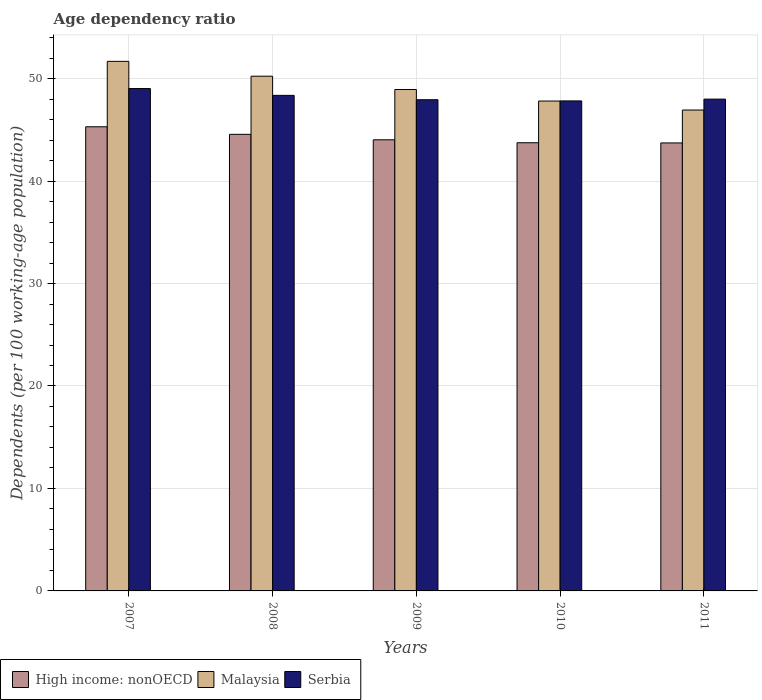How many bars are there on the 4th tick from the right?
Your response must be concise. 3. What is the age dependency ratio in in Serbia in 2008?
Your answer should be compact. 48.36. Across all years, what is the maximum age dependency ratio in in High income: nonOECD?
Make the answer very short. 45.3. Across all years, what is the minimum age dependency ratio in in Malaysia?
Keep it short and to the point. 46.93. What is the total age dependency ratio in in High income: nonOECD in the graph?
Your response must be concise. 221.35. What is the difference between the age dependency ratio in in High income: nonOECD in 2007 and that in 2011?
Offer a very short reply. 1.58. What is the difference between the age dependency ratio in in Serbia in 2011 and the age dependency ratio in in High income: nonOECD in 2009?
Ensure brevity in your answer.  3.97. What is the average age dependency ratio in in Malaysia per year?
Make the answer very short. 49.12. In the year 2008, what is the difference between the age dependency ratio in in Malaysia and age dependency ratio in in High income: nonOECD?
Your answer should be compact. 5.67. In how many years, is the age dependency ratio in in High income: nonOECD greater than 14 %?
Your answer should be compact. 5. What is the ratio of the age dependency ratio in in High income: nonOECD in 2007 to that in 2011?
Your response must be concise. 1.04. Is the age dependency ratio in in Serbia in 2008 less than that in 2009?
Your answer should be very brief. No. Is the difference between the age dependency ratio in in Malaysia in 2007 and 2010 greater than the difference between the age dependency ratio in in High income: nonOECD in 2007 and 2010?
Provide a succinct answer. Yes. What is the difference between the highest and the second highest age dependency ratio in in Serbia?
Offer a terse response. 0.66. What is the difference between the highest and the lowest age dependency ratio in in Serbia?
Your response must be concise. 1.21. What does the 3rd bar from the left in 2011 represents?
Give a very brief answer. Serbia. What does the 1st bar from the right in 2010 represents?
Ensure brevity in your answer.  Serbia. Is it the case that in every year, the sum of the age dependency ratio in in Serbia and age dependency ratio in in Malaysia is greater than the age dependency ratio in in High income: nonOECD?
Your answer should be very brief. Yes. How many bars are there?
Your answer should be very brief. 15. What is the difference between two consecutive major ticks on the Y-axis?
Make the answer very short. 10. Are the values on the major ticks of Y-axis written in scientific E-notation?
Ensure brevity in your answer.  No. Does the graph contain grids?
Your response must be concise. Yes. How are the legend labels stacked?
Make the answer very short. Horizontal. What is the title of the graph?
Your response must be concise. Age dependency ratio. What is the label or title of the X-axis?
Provide a succinct answer. Years. What is the label or title of the Y-axis?
Keep it short and to the point. Dependents (per 100 working-age population). What is the Dependents (per 100 working-age population) of High income: nonOECD in 2007?
Your answer should be very brief. 45.3. What is the Dependents (per 100 working-age population) of Malaysia in 2007?
Your response must be concise. 51.68. What is the Dependents (per 100 working-age population) in Serbia in 2007?
Make the answer very short. 49.03. What is the Dependents (per 100 working-age population) in High income: nonOECD in 2008?
Make the answer very short. 44.56. What is the Dependents (per 100 working-age population) of Malaysia in 2008?
Offer a terse response. 50.23. What is the Dependents (per 100 working-age population) in Serbia in 2008?
Your answer should be very brief. 48.36. What is the Dependents (per 100 working-age population) in High income: nonOECD in 2009?
Your response must be concise. 44.03. What is the Dependents (per 100 working-age population) in Malaysia in 2009?
Keep it short and to the point. 48.94. What is the Dependents (per 100 working-age population) of Serbia in 2009?
Your answer should be compact. 47.94. What is the Dependents (per 100 working-age population) of High income: nonOECD in 2010?
Offer a terse response. 43.74. What is the Dependents (per 100 working-age population) of Malaysia in 2010?
Your answer should be compact. 47.81. What is the Dependents (per 100 working-age population) in Serbia in 2010?
Your answer should be very brief. 47.82. What is the Dependents (per 100 working-age population) in High income: nonOECD in 2011?
Give a very brief answer. 43.72. What is the Dependents (per 100 working-age population) in Malaysia in 2011?
Your answer should be compact. 46.93. What is the Dependents (per 100 working-age population) of Serbia in 2011?
Make the answer very short. 48. Across all years, what is the maximum Dependents (per 100 working-age population) of High income: nonOECD?
Your answer should be compact. 45.3. Across all years, what is the maximum Dependents (per 100 working-age population) of Malaysia?
Your answer should be very brief. 51.68. Across all years, what is the maximum Dependents (per 100 working-age population) in Serbia?
Your answer should be very brief. 49.03. Across all years, what is the minimum Dependents (per 100 working-age population) in High income: nonOECD?
Keep it short and to the point. 43.72. Across all years, what is the minimum Dependents (per 100 working-age population) of Malaysia?
Your answer should be very brief. 46.93. Across all years, what is the minimum Dependents (per 100 working-age population) of Serbia?
Give a very brief answer. 47.82. What is the total Dependents (per 100 working-age population) in High income: nonOECD in the graph?
Provide a short and direct response. 221.35. What is the total Dependents (per 100 working-age population) of Malaysia in the graph?
Give a very brief answer. 245.6. What is the total Dependents (per 100 working-age population) in Serbia in the graph?
Your response must be concise. 241.15. What is the difference between the Dependents (per 100 working-age population) in High income: nonOECD in 2007 and that in 2008?
Offer a very short reply. 0.74. What is the difference between the Dependents (per 100 working-age population) in Malaysia in 2007 and that in 2008?
Offer a terse response. 1.45. What is the difference between the Dependents (per 100 working-age population) of Serbia in 2007 and that in 2008?
Offer a terse response. 0.66. What is the difference between the Dependents (per 100 working-age population) of High income: nonOECD in 2007 and that in 2009?
Provide a succinct answer. 1.27. What is the difference between the Dependents (per 100 working-age population) in Malaysia in 2007 and that in 2009?
Your response must be concise. 2.75. What is the difference between the Dependents (per 100 working-age population) in Serbia in 2007 and that in 2009?
Your answer should be very brief. 1.09. What is the difference between the Dependents (per 100 working-age population) in High income: nonOECD in 2007 and that in 2010?
Your response must be concise. 1.56. What is the difference between the Dependents (per 100 working-age population) in Malaysia in 2007 and that in 2010?
Provide a short and direct response. 3.87. What is the difference between the Dependents (per 100 working-age population) in Serbia in 2007 and that in 2010?
Offer a terse response. 1.21. What is the difference between the Dependents (per 100 working-age population) of High income: nonOECD in 2007 and that in 2011?
Your answer should be compact. 1.58. What is the difference between the Dependents (per 100 working-age population) of Malaysia in 2007 and that in 2011?
Your response must be concise. 4.75. What is the difference between the Dependents (per 100 working-age population) in Serbia in 2007 and that in 2011?
Keep it short and to the point. 1.03. What is the difference between the Dependents (per 100 working-age population) in High income: nonOECD in 2008 and that in 2009?
Offer a terse response. 0.53. What is the difference between the Dependents (per 100 working-age population) of Malaysia in 2008 and that in 2009?
Provide a short and direct response. 1.3. What is the difference between the Dependents (per 100 working-age population) of Serbia in 2008 and that in 2009?
Your response must be concise. 0.43. What is the difference between the Dependents (per 100 working-age population) in High income: nonOECD in 2008 and that in 2010?
Offer a terse response. 0.82. What is the difference between the Dependents (per 100 working-age population) in Malaysia in 2008 and that in 2010?
Your answer should be very brief. 2.42. What is the difference between the Dependents (per 100 working-age population) of Serbia in 2008 and that in 2010?
Offer a terse response. 0.54. What is the difference between the Dependents (per 100 working-age population) in High income: nonOECD in 2008 and that in 2011?
Give a very brief answer. 0.84. What is the difference between the Dependents (per 100 working-age population) in Malaysia in 2008 and that in 2011?
Offer a very short reply. 3.3. What is the difference between the Dependents (per 100 working-age population) of Serbia in 2008 and that in 2011?
Provide a short and direct response. 0.37. What is the difference between the Dependents (per 100 working-age population) in High income: nonOECD in 2009 and that in 2010?
Offer a very short reply. 0.29. What is the difference between the Dependents (per 100 working-age population) of Malaysia in 2009 and that in 2010?
Provide a short and direct response. 1.13. What is the difference between the Dependents (per 100 working-age population) of Serbia in 2009 and that in 2010?
Give a very brief answer. 0.12. What is the difference between the Dependents (per 100 working-age population) of High income: nonOECD in 2009 and that in 2011?
Offer a very short reply. 0.31. What is the difference between the Dependents (per 100 working-age population) of Malaysia in 2009 and that in 2011?
Make the answer very short. 2. What is the difference between the Dependents (per 100 working-age population) of Serbia in 2009 and that in 2011?
Ensure brevity in your answer.  -0.06. What is the difference between the Dependents (per 100 working-age population) of High income: nonOECD in 2010 and that in 2011?
Provide a succinct answer. 0.02. What is the difference between the Dependents (per 100 working-age population) of Malaysia in 2010 and that in 2011?
Your response must be concise. 0.88. What is the difference between the Dependents (per 100 working-age population) in Serbia in 2010 and that in 2011?
Make the answer very short. -0.17. What is the difference between the Dependents (per 100 working-age population) of High income: nonOECD in 2007 and the Dependents (per 100 working-age population) of Malaysia in 2008?
Provide a short and direct response. -4.94. What is the difference between the Dependents (per 100 working-age population) in High income: nonOECD in 2007 and the Dependents (per 100 working-age population) in Serbia in 2008?
Keep it short and to the point. -3.07. What is the difference between the Dependents (per 100 working-age population) in Malaysia in 2007 and the Dependents (per 100 working-age population) in Serbia in 2008?
Offer a very short reply. 3.32. What is the difference between the Dependents (per 100 working-age population) of High income: nonOECD in 2007 and the Dependents (per 100 working-age population) of Malaysia in 2009?
Make the answer very short. -3.64. What is the difference between the Dependents (per 100 working-age population) in High income: nonOECD in 2007 and the Dependents (per 100 working-age population) in Serbia in 2009?
Your answer should be compact. -2.64. What is the difference between the Dependents (per 100 working-age population) of Malaysia in 2007 and the Dependents (per 100 working-age population) of Serbia in 2009?
Your answer should be very brief. 3.75. What is the difference between the Dependents (per 100 working-age population) in High income: nonOECD in 2007 and the Dependents (per 100 working-age population) in Malaysia in 2010?
Provide a succinct answer. -2.51. What is the difference between the Dependents (per 100 working-age population) in High income: nonOECD in 2007 and the Dependents (per 100 working-age population) in Serbia in 2010?
Provide a succinct answer. -2.52. What is the difference between the Dependents (per 100 working-age population) in Malaysia in 2007 and the Dependents (per 100 working-age population) in Serbia in 2010?
Offer a very short reply. 3.86. What is the difference between the Dependents (per 100 working-age population) of High income: nonOECD in 2007 and the Dependents (per 100 working-age population) of Malaysia in 2011?
Your answer should be very brief. -1.63. What is the difference between the Dependents (per 100 working-age population) of High income: nonOECD in 2007 and the Dependents (per 100 working-age population) of Serbia in 2011?
Provide a succinct answer. -2.7. What is the difference between the Dependents (per 100 working-age population) in Malaysia in 2007 and the Dependents (per 100 working-age population) in Serbia in 2011?
Give a very brief answer. 3.69. What is the difference between the Dependents (per 100 working-age population) in High income: nonOECD in 2008 and the Dependents (per 100 working-age population) in Malaysia in 2009?
Your answer should be very brief. -4.38. What is the difference between the Dependents (per 100 working-age population) of High income: nonOECD in 2008 and the Dependents (per 100 working-age population) of Serbia in 2009?
Offer a very short reply. -3.38. What is the difference between the Dependents (per 100 working-age population) in Malaysia in 2008 and the Dependents (per 100 working-age population) in Serbia in 2009?
Keep it short and to the point. 2.3. What is the difference between the Dependents (per 100 working-age population) in High income: nonOECD in 2008 and the Dependents (per 100 working-age population) in Malaysia in 2010?
Offer a terse response. -3.25. What is the difference between the Dependents (per 100 working-age population) of High income: nonOECD in 2008 and the Dependents (per 100 working-age population) of Serbia in 2010?
Provide a succinct answer. -3.26. What is the difference between the Dependents (per 100 working-age population) of Malaysia in 2008 and the Dependents (per 100 working-age population) of Serbia in 2010?
Your answer should be compact. 2.41. What is the difference between the Dependents (per 100 working-age population) of High income: nonOECD in 2008 and the Dependents (per 100 working-age population) of Malaysia in 2011?
Your answer should be very brief. -2.37. What is the difference between the Dependents (per 100 working-age population) in High income: nonOECD in 2008 and the Dependents (per 100 working-age population) in Serbia in 2011?
Provide a short and direct response. -3.44. What is the difference between the Dependents (per 100 working-age population) of Malaysia in 2008 and the Dependents (per 100 working-age population) of Serbia in 2011?
Ensure brevity in your answer.  2.24. What is the difference between the Dependents (per 100 working-age population) in High income: nonOECD in 2009 and the Dependents (per 100 working-age population) in Malaysia in 2010?
Provide a succinct answer. -3.78. What is the difference between the Dependents (per 100 working-age population) in High income: nonOECD in 2009 and the Dependents (per 100 working-age population) in Serbia in 2010?
Your answer should be compact. -3.8. What is the difference between the Dependents (per 100 working-age population) in Malaysia in 2009 and the Dependents (per 100 working-age population) in Serbia in 2010?
Ensure brevity in your answer.  1.12. What is the difference between the Dependents (per 100 working-age population) in High income: nonOECD in 2009 and the Dependents (per 100 working-age population) in Malaysia in 2011?
Your answer should be compact. -2.91. What is the difference between the Dependents (per 100 working-age population) of High income: nonOECD in 2009 and the Dependents (per 100 working-age population) of Serbia in 2011?
Offer a terse response. -3.97. What is the difference between the Dependents (per 100 working-age population) of Malaysia in 2009 and the Dependents (per 100 working-age population) of Serbia in 2011?
Give a very brief answer. 0.94. What is the difference between the Dependents (per 100 working-age population) in High income: nonOECD in 2010 and the Dependents (per 100 working-age population) in Malaysia in 2011?
Your answer should be compact. -3.19. What is the difference between the Dependents (per 100 working-age population) of High income: nonOECD in 2010 and the Dependents (per 100 working-age population) of Serbia in 2011?
Offer a very short reply. -4.26. What is the difference between the Dependents (per 100 working-age population) of Malaysia in 2010 and the Dependents (per 100 working-age population) of Serbia in 2011?
Keep it short and to the point. -0.19. What is the average Dependents (per 100 working-age population) in High income: nonOECD per year?
Ensure brevity in your answer.  44.27. What is the average Dependents (per 100 working-age population) of Malaysia per year?
Ensure brevity in your answer.  49.12. What is the average Dependents (per 100 working-age population) of Serbia per year?
Provide a short and direct response. 48.23. In the year 2007, what is the difference between the Dependents (per 100 working-age population) in High income: nonOECD and Dependents (per 100 working-age population) in Malaysia?
Your answer should be very brief. -6.38. In the year 2007, what is the difference between the Dependents (per 100 working-age population) of High income: nonOECD and Dependents (per 100 working-age population) of Serbia?
Your answer should be compact. -3.73. In the year 2007, what is the difference between the Dependents (per 100 working-age population) in Malaysia and Dependents (per 100 working-age population) in Serbia?
Make the answer very short. 2.65. In the year 2008, what is the difference between the Dependents (per 100 working-age population) of High income: nonOECD and Dependents (per 100 working-age population) of Malaysia?
Give a very brief answer. -5.67. In the year 2008, what is the difference between the Dependents (per 100 working-age population) in High income: nonOECD and Dependents (per 100 working-age population) in Serbia?
Your answer should be compact. -3.8. In the year 2008, what is the difference between the Dependents (per 100 working-age population) of Malaysia and Dependents (per 100 working-age population) of Serbia?
Your answer should be compact. 1.87. In the year 2009, what is the difference between the Dependents (per 100 working-age population) of High income: nonOECD and Dependents (per 100 working-age population) of Malaysia?
Provide a short and direct response. -4.91. In the year 2009, what is the difference between the Dependents (per 100 working-age population) of High income: nonOECD and Dependents (per 100 working-age population) of Serbia?
Offer a terse response. -3.91. In the year 2010, what is the difference between the Dependents (per 100 working-age population) in High income: nonOECD and Dependents (per 100 working-age population) in Malaysia?
Your answer should be very brief. -4.07. In the year 2010, what is the difference between the Dependents (per 100 working-age population) of High income: nonOECD and Dependents (per 100 working-age population) of Serbia?
Provide a short and direct response. -4.08. In the year 2010, what is the difference between the Dependents (per 100 working-age population) in Malaysia and Dependents (per 100 working-age population) in Serbia?
Keep it short and to the point. -0.01. In the year 2011, what is the difference between the Dependents (per 100 working-age population) of High income: nonOECD and Dependents (per 100 working-age population) of Malaysia?
Make the answer very short. -3.21. In the year 2011, what is the difference between the Dependents (per 100 working-age population) of High income: nonOECD and Dependents (per 100 working-age population) of Serbia?
Provide a short and direct response. -4.28. In the year 2011, what is the difference between the Dependents (per 100 working-age population) in Malaysia and Dependents (per 100 working-age population) in Serbia?
Make the answer very short. -1.06. What is the ratio of the Dependents (per 100 working-age population) of High income: nonOECD in 2007 to that in 2008?
Make the answer very short. 1.02. What is the ratio of the Dependents (per 100 working-age population) in Malaysia in 2007 to that in 2008?
Offer a terse response. 1.03. What is the ratio of the Dependents (per 100 working-age population) in Serbia in 2007 to that in 2008?
Provide a succinct answer. 1.01. What is the ratio of the Dependents (per 100 working-age population) in High income: nonOECD in 2007 to that in 2009?
Offer a terse response. 1.03. What is the ratio of the Dependents (per 100 working-age population) of Malaysia in 2007 to that in 2009?
Provide a succinct answer. 1.06. What is the ratio of the Dependents (per 100 working-age population) in Serbia in 2007 to that in 2009?
Ensure brevity in your answer.  1.02. What is the ratio of the Dependents (per 100 working-age population) in High income: nonOECD in 2007 to that in 2010?
Offer a terse response. 1.04. What is the ratio of the Dependents (per 100 working-age population) of Malaysia in 2007 to that in 2010?
Your response must be concise. 1.08. What is the ratio of the Dependents (per 100 working-age population) of Serbia in 2007 to that in 2010?
Offer a terse response. 1.03. What is the ratio of the Dependents (per 100 working-age population) of High income: nonOECD in 2007 to that in 2011?
Make the answer very short. 1.04. What is the ratio of the Dependents (per 100 working-age population) of Malaysia in 2007 to that in 2011?
Keep it short and to the point. 1.1. What is the ratio of the Dependents (per 100 working-age population) in Serbia in 2007 to that in 2011?
Offer a very short reply. 1.02. What is the ratio of the Dependents (per 100 working-age population) of High income: nonOECD in 2008 to that in 2009?
Provide a short and direct response. 1.01. What is the ratio of the Dependents (per 100 working-age population) in Malaysia in 2008 to that in 2009?
Give a very brief answer. 1.03. What is the ratio of the Dependents (per 100 working-age population) in Serbia in 2008 to that in 2009?
Make the answer very short. 1.01. What is the ratio of the Dependents (per 100 working-age population) of High income: nonOECD in 2008 to that in 2010?
Your answer should be very brief. 1.02. What is the ratio of the Dependents (per 100 working-age population) in Malaysia in 2008 to that in 2010?
Ensure brevity in your answer.  1.05. What is the ratio of the Dependents (per 100 working-age population) in Serbia in 2008 to that in 2010?
Your answer should be compact. 1.01. What is the ratio of the Dependents (per 100 working-age population) of High income: nonOECD in 2008 to that in 2011?
Keep it short and to the point. 1.02. What is the ratio of the Dependents (per 100 working-age population) in Malaysia in 2008 to that in 2011?
Provide a succinct answer. 1.07. What is the ratio of the Dependents (per 100 working-age population) in Serbia in 2008 to that in 2011?
Your response must be concise. 1.01. What is the ratio of the Dependents (per 100 working-age population) in High income: nonOECD in 2009 to that in 2010?
Your response must be concise. 1.01. What is the ratio of the Dependents (per 100 working-age population) of Malaysia in 2009 to that in 2010?
Provide a short and direct response. 1.02. What is the ratio of the Dependents (per 100 working-age population) of Serbia in 2009 to that in 2010?
Your answer should be compact. 1. What is the ratio of the Dependents (per 100 working-age population) in Malaysia in 2009 to that in 2011?
Offer a terse response. 1.04. What is the ratio of the Dependents (per 100 working-age population) of Serbia in 2009 to that in 2011?
Your answer should be very brief. 1. What is the ratio of the Dependents (per 100 working-age population) of High income: nonOECD in 2010 to that in 2011?
Your response must be concise. 1. What is the ratio of the Dependents (per 100 working-age population) in Malaysia in 2010 to that in 2011?
Your response must be concise. 1.02. What is the difference between the highest and the second highest Dependents (per 100 working-age population) in High income: nonOECD?
Your response must be concise. 0.74. What is the difference between the highest and the second highest Dependents (per 100 working-age population) in Malaysia?
Your answer should be compact. 1.45. What is the difference between the highest and the second highest Dependents (per 100 working-age population) of Serbia?
Provide a succinct answer. 0.66. What is the difference between the highest and the lowest Dependents (per 100 working-age population) of High income: nonOECD?
Your response must be concise. 1.58. What is the difference between the highest and the lowest Dependents (per 100 working-age population) in Malaysia?
Ensure brevity in your answer.  4.75. What is the difference between the highest and the lowest Dependents (per 100 working-age population) in Serbia?
Offer a terse response. 1.21. 